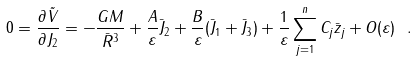<formula> <loc_0><loc_0><loc_500><loc_500>0 = \frac { \partial \tilde { V } } { \partial J _ { 2 } } = - \frac { G M } { \bar { R } ^ { 3 } } + \frac { A } { \varepsilon } \bar { J } _ { 2 } + \frac { B } { \varepsilon } ( \bar { J } _ { 1 } + \bar { J } _ { 3 } ) + \frac { 1 } { \varepsilon } \sum _ { j = 1 } ^ { n } C _ { j } \bar { z } _ { j } + O ( \varepsilon ) \ .</formula> 